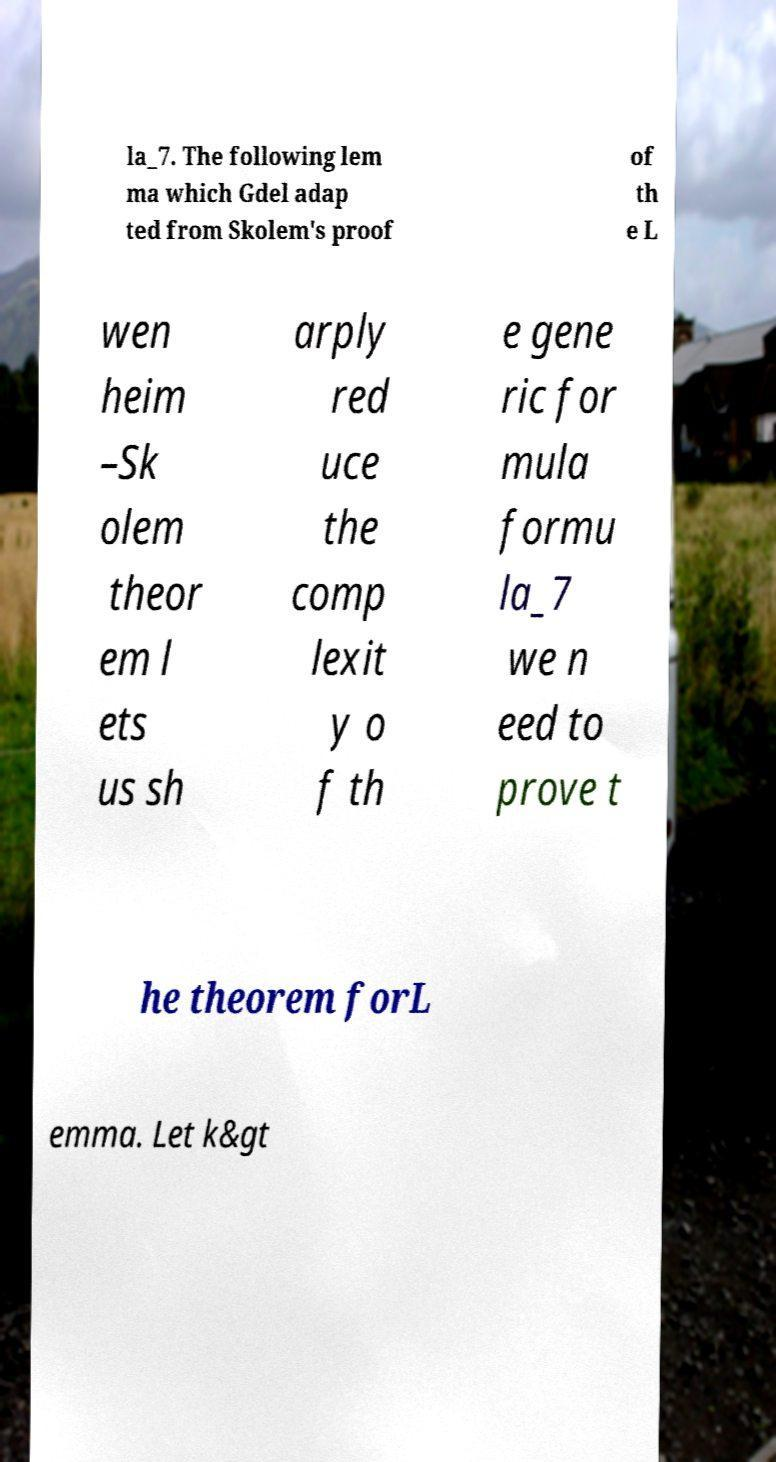I need the written content from this picture converted into text. Can you do that? la_7. The following lem ma which Gdel adap ted from Skolem's proof of th e L wen heim –Sk olem theor em l ets us sh arply red uce the comp lexit y o f th e gene ric for mula formu la_7 we n eed to prove t he theorem forL emma. Let k&gt 